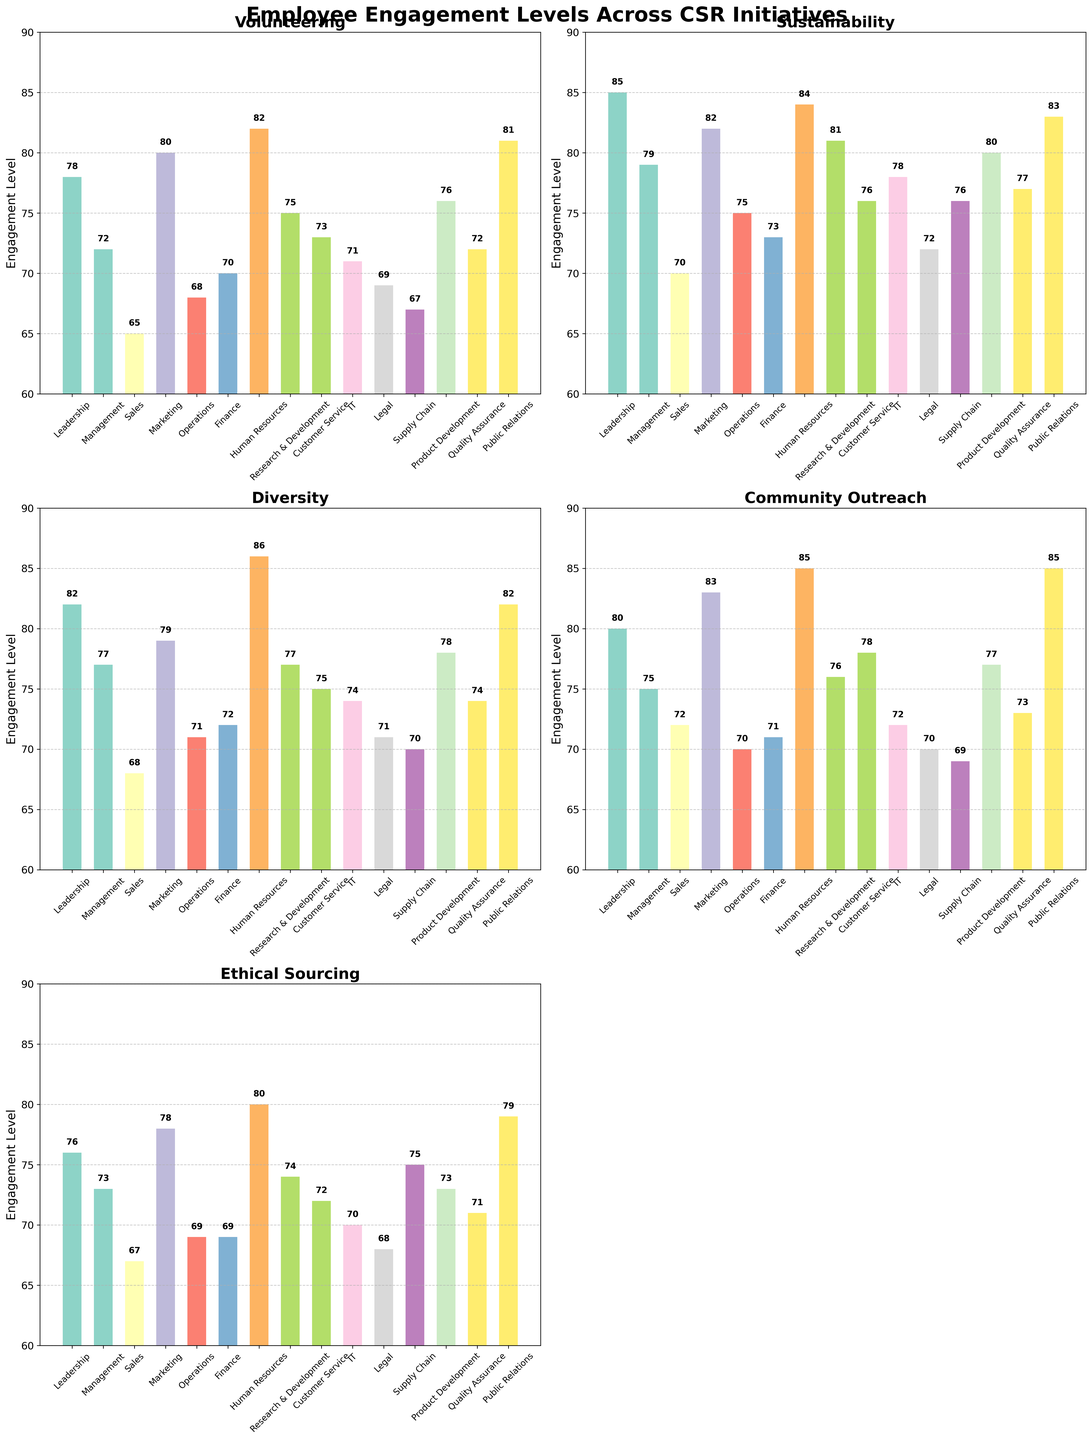What is the department with the highest engagement in Sustainability? The bar with the greatest height in the Sustainability subplot needs to be identified. Human Resources (84) has the highest level.
Answer: Human Resources Which departments have higher engagement in Community Outreach compared to Volunteering? Look at the bars for Community Outreach and Volunteering side by side for each department. Marketing, Human Resources, Public Relations, and Customer Service show higher engagement in Community Outreach.
Answer: Marketing, Human Resources, Public Relations, Customer Service What is the average engagement level across all initiatives for the Sales department? Calculate the average by summing engagements across all initiatives for Sales (65 + 70 + 68 + 72 + 67) and dividing by the number of initiatives (5). The total is 342, so the average is 342/5.
Answer: 68.4 Which initiative has the smallest range of engagement levels across all departments? For each initiative subplot, find the difference between the highest and lowest bars. Ethical Sourcing has the smallest range (85 - 67 = 18).
Answer: Ethical Sourcing For Research & Development, what is the difference in engagement levels between Diversity and Volunteering? Subtract the engagement level of Volunteering (75) from that of Diversity (77).
Answer: 2 List the three departments with the highest engagement in Ethical Sourcing. Identify the three tallest bars in the Ethical Sourcing subplot. They belong to Public Relations (79), Marketing (78), and Human Resources (80).
Answer: Human Resources, Marketing, Public Relations In which initiative does Leadership have the lowest engagement level? Find the shortest bar in the Leadership series across all subplot bars. It corresponds to Ethical Sourcing (76).
Answer: Ethical Sourcing What is the total engagement for the Operations department across all initiatives? Sum up the Operations engagement levels for all initiatives (68 + 75 + 71 + 70 + 69), which equals 353.
Answer: 353 